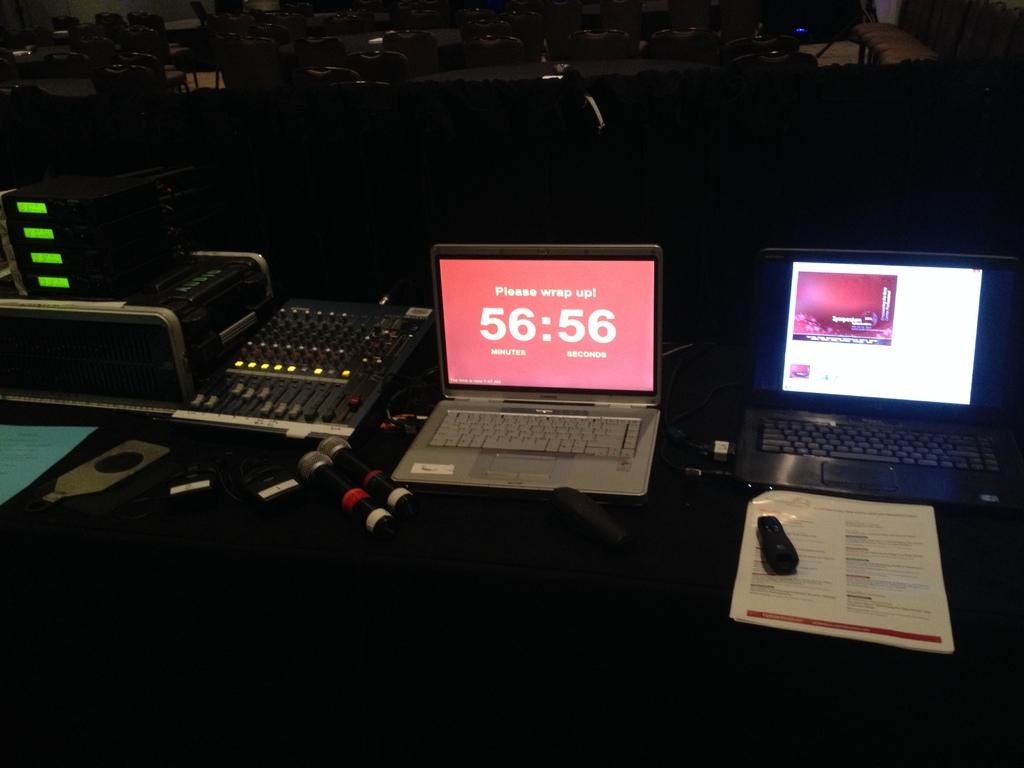How much time is remaining?
Your answer should be compact. 56:56. What is the first line written above the timer on the laptop?
Ensure brevity in your answer.  Please wrap up!. 